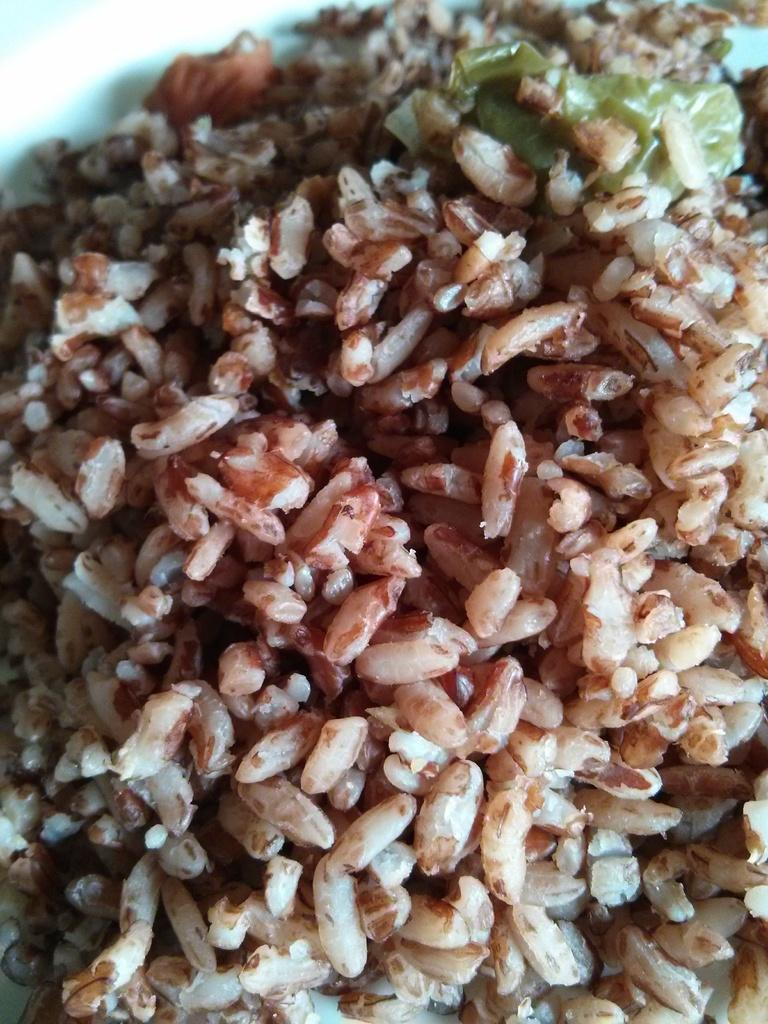What type of food is in the center of the image? There is brown rice in the center of the image. What type of belief is depicted in the image? There is no belief depicted in the image; it only shows brown rice. What type of instrument is being played in the image? There is no instrument being played in the image; it only shows brown rice. 